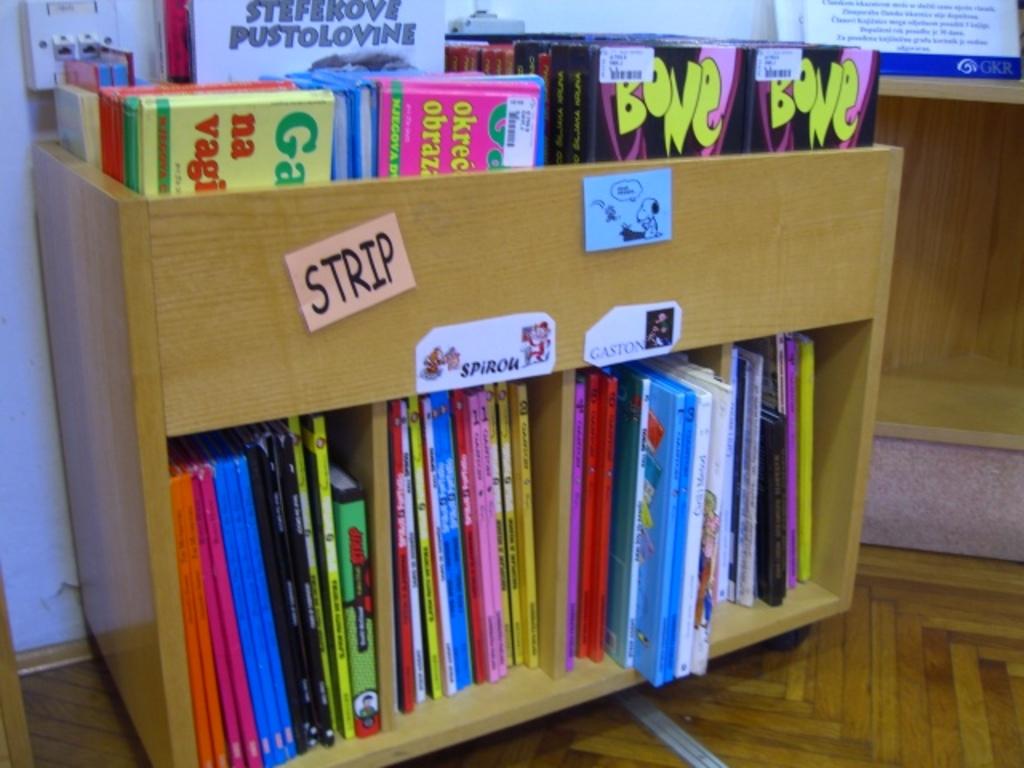What color is the font in the title bone?
Provide a succinct answer. Yellow. What does the post it say?
Give a very brief answer. Strip. 